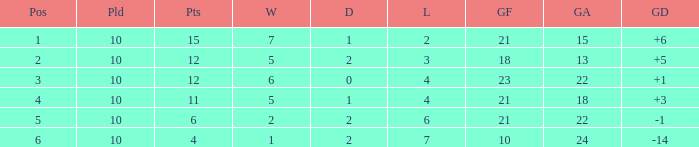Would you mind parsing the complete table? {'header': ['Pos', 'Pld', 'Pts', 'W', 'D', 'L', 'GF', 'GA', 'GD'], 'rows': [['1', '10', '15', '7', '1', '2', '21', '15', '+6'], ['2', '10', '12', '5', '2', '3', '18', '13', '+5'], ['3', '10', '12', '6', '0', '4', '23', '22', '+1'], ['4', '10', '11', '5', '1', '4', '21', '18', '+3'], ['5', '10', '6', '2', '2', '6', '21', '22', '-1'], ['6', '10', '4', '1', '2', '7', '10', '24', '-14']]} Can you tell me the total number of Wins that has the Draws larger than 0, and the Points of 11? 1.0. 